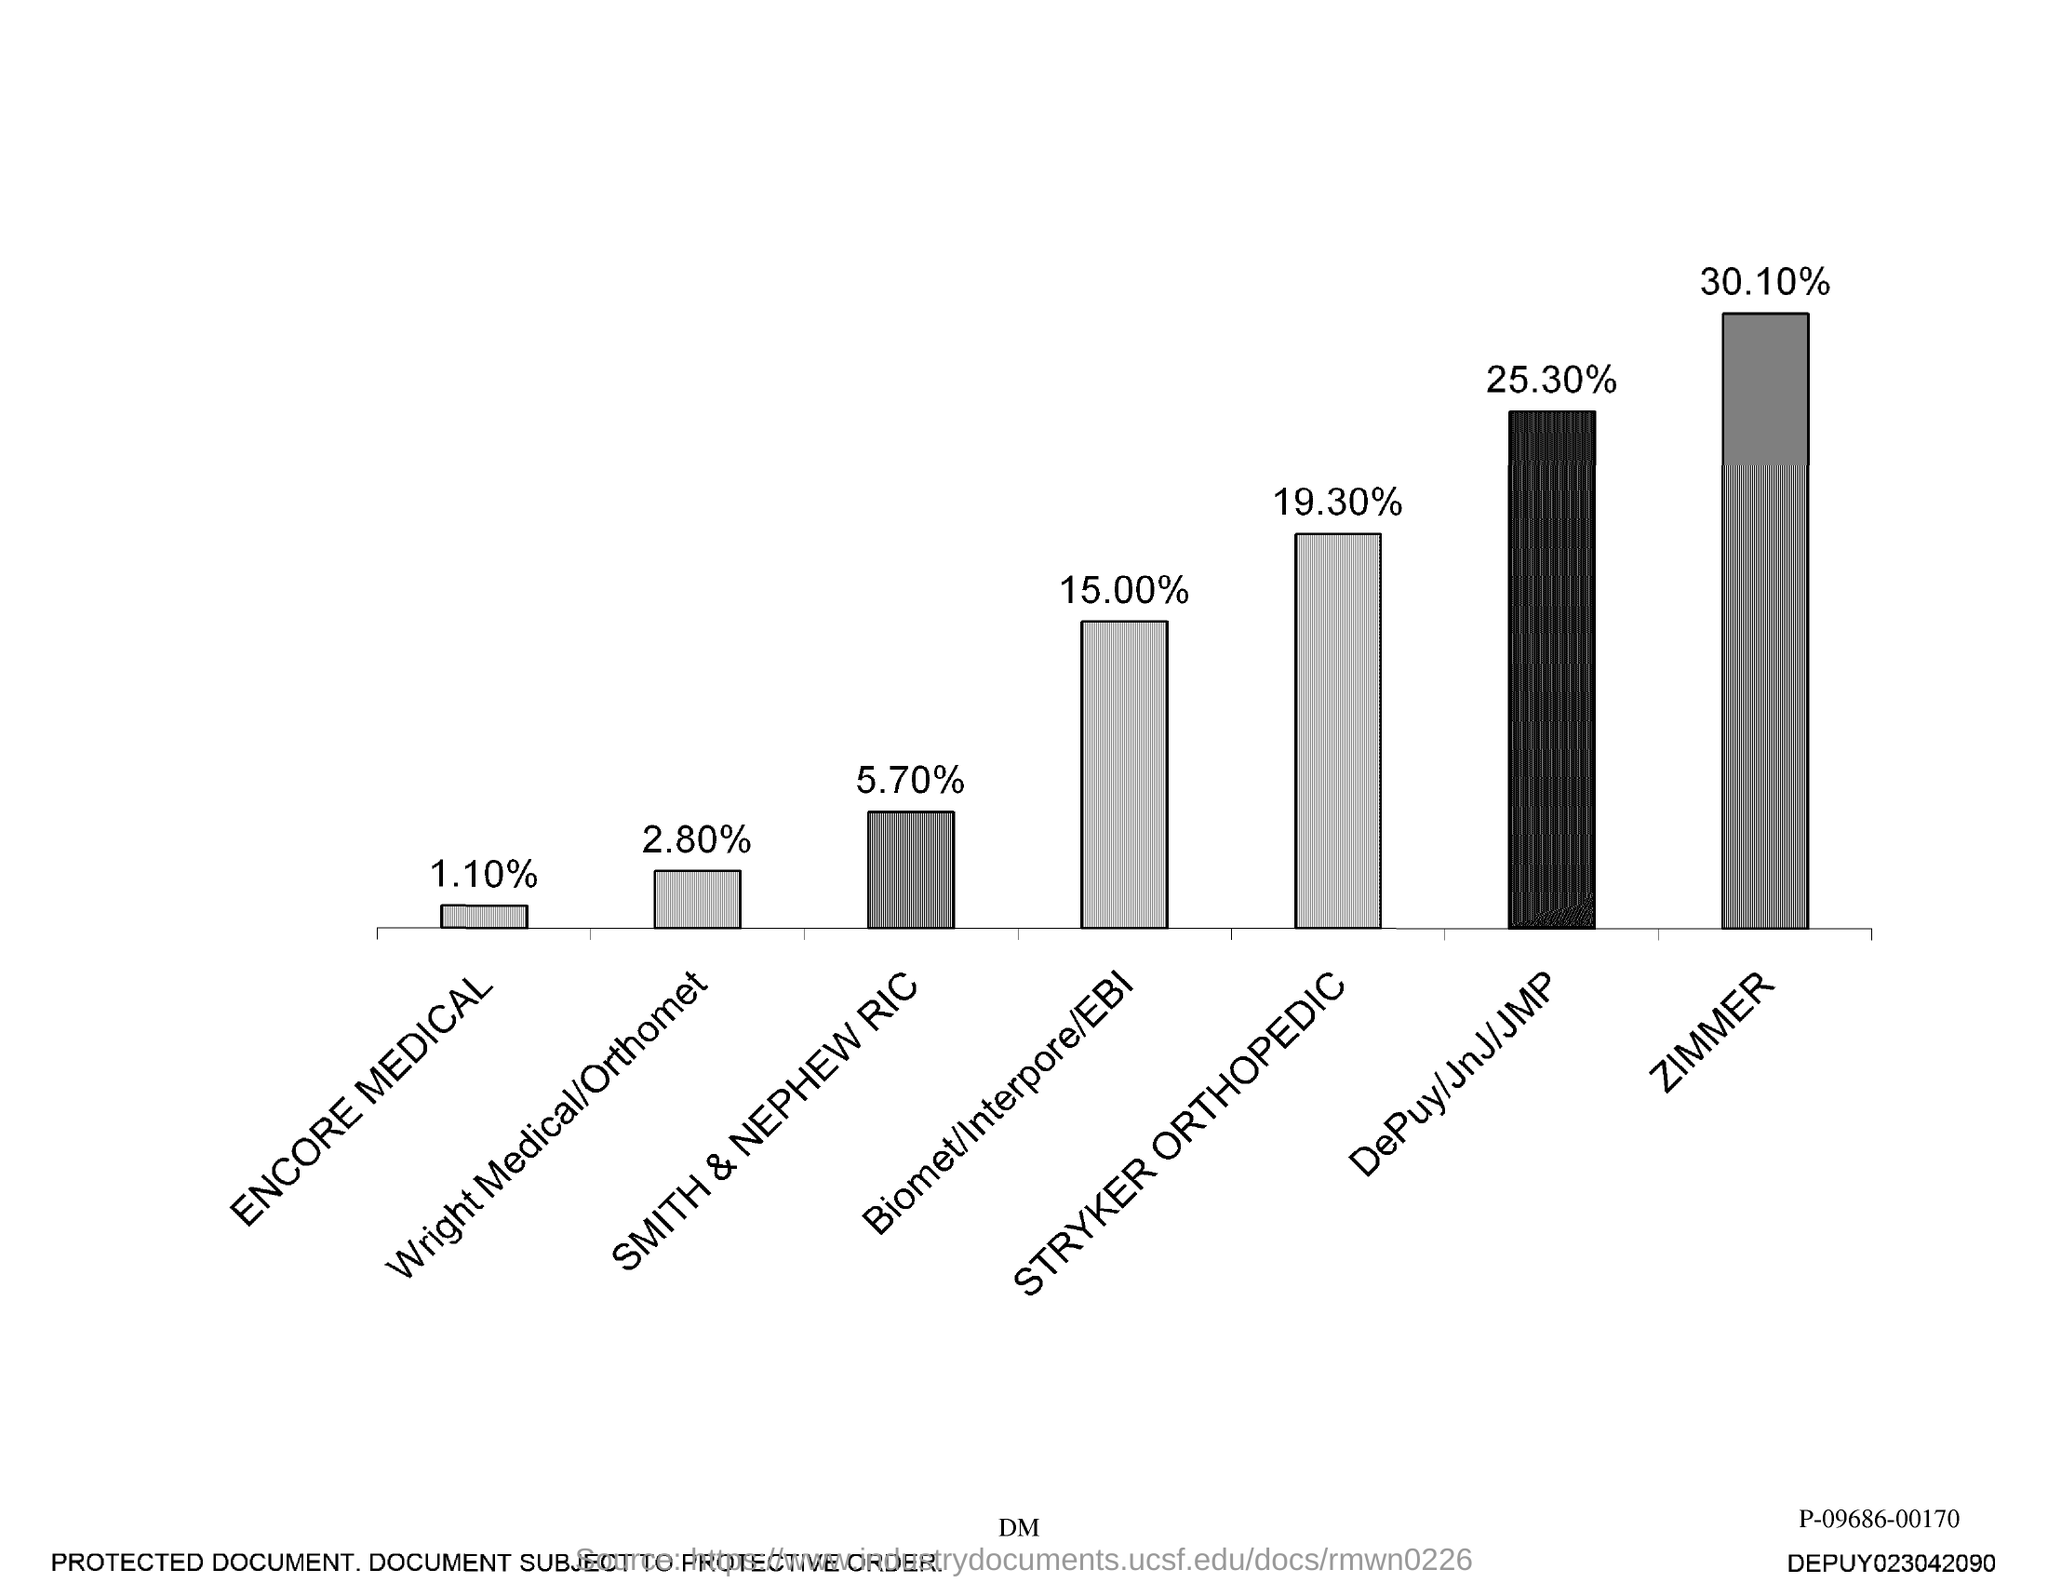Highlight a few significant elements in this photo. The graph displays the highest value of 30.10%, indicating a high level of performance or achievement. According to the graph, the lowest value was 1.10%. 